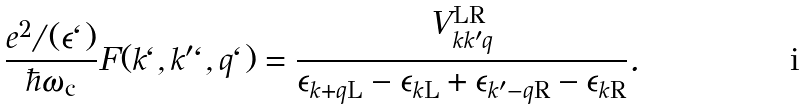<formula> <loc_0><loc_0><loc_500><loc_500>\frac { e ^ { 2 } / ( \epsilon \ell ) } { \hbar { \omega } _ { \text {c} } } F ( k \ell , k ^ { \prime } \ell , q \ell ) = \frac { V _ { k k ^ { \prime } q } ^ { \text {LR} } } { \epsilon _ { k + q \text {L} } - \epsilon _ { k \text {L} } + \epsilon _ { k ^ { \prime } - q \text {R} } - \epsilon _ { k \text {R} } } . \,</formula> 